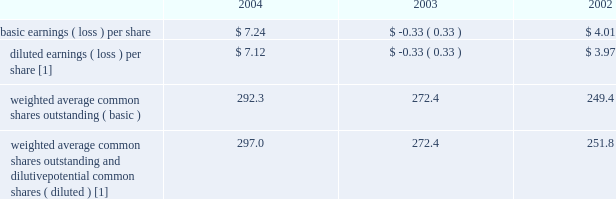Income was due primarily to the adoption of statement of position 03-1 , 201caccounting and reporting by insurance enterprises for certain nontraditional long-duration contracts and for separate accounts 201d ( 201csop 03-1 201d ) , which resulted in $ 1.6 billion of net investment income .
2003 compared to 2002 2014 revenues for the year ended december 31 , 2003 increased $ 2.3 billion over the comparable 2002 period .
Revenues increased due to earned premium growth within the business insurance , specialty commercial and personal lines segments , primarily as a result of earned pricing increases , higher earned premiums and net investment income in the retail products segment and net realized capital gains in 2003 as compared to net realized capital losses in 2002 .
Total benefits , claims and expenses increased $ 3.9 billion for the year ended december 31 , 2003 over the comparable prior year period primarily due to the company 2019s $ 2.6 billion asbestos reserve strengthening during the first quarter of 2003 and due to increases in the retail products segment associated with the growth in the individual annuity and institutional investments businesses .
The net loss for the year ended december 31 , 2003 was primarily due to the company 2019s first quarter 2003 asbestos reserve strengthening of $ 1.7 billion , after-tax .
Included in net loss for the year ended december 31 , 2003 are $ 40 of after-tax expense related to the settlement of litigation with bancorp services , llc ( 201cbancorp 201d ) and $ 27 of severance charges , after-tax , in property & casualty .
Included in net income for the year ended december 31 , 2002 are the $ 8 after-tax benefit recognized by hartford life , inc .
( 201chli 201d ) related to the reduction of hli 2019s reserves associated with september 11 and $ 11 of after-tax expense related to litigation with bancorp .
Net realized capital gains and losses see 201cinvestment results 201d in the investments section .
Income taxes the effective tax rate for 2004 , 2003 and 2002 was 15% ( 15 % ) , 83% ( 83 % ) and 6% ( 6 % ) , respectively .
The principal causes of the difference between the effective rates and the u.s .
Statutory rate of 35% ( 35 % ) were tax-exempt interest earned on invested assets , the dividends-received deduction , the tax benefit associated with the settlement of the 1998-2001 irs audit in 2004 and the tax benefit associated with the settlement of the 1996-1997 irs audit in 2002 .
Income taxes paid ( received ) in 2004 , 2003 and 2002 were $ 32 , ( $ 107 ) and ( $ 102 ) respectively .
For additional information , see note 13 of notes to consolidated financial statements .
Per common share the table represents earnings per common share data for the past three years: .
[1] as a result of the net loss for the year ended december 31 , 2003 , sfas no .
128 , 201cearnings per share 201d , requires the company to use basic weighted average common shares outstanding in the calculation of the year ended december 31 , 2003 diluted earnings ( loss ) per share , since the inclusion of options of 1.8 would have been antidilutive to the earnings per share calculation .
In the absence of the net loss , weighted average common shares outstanding and dilutive potential common shares would have totaled 274.2 .
Executive overview the company provides investment and retirement products such as variable and fixed annuities , mutual funds and retirement plan services and other institutional products ; individual and corporate owned life insurance ; and , group benefit products , such as group life and group disability insurance .
The company derives its revenues principally from : ( a ) fee income , including asset management fees , on separate account and mutual fund assets and mortality and expense fees , as well as cost of insurance charges ; ( b ) net investment income on general account assets ; ( c ) fully insured premiums ; and ( d ) certain other fees .
Asset management fees and mortality and expense fees are primarily generated from separate account assets , which are deposited with the company through the sale of variable annuity and variable universal life products and from mutual funds .
Cost of insurance charges are assessed on the net amount at risk for investment-oriented life insurance products .
Premium revenues are derived primarily from the sale of group life , and group disability and individual term insurance products .
The company 2019s expenses essentially consist of interest credited to policyholders on general account liabilities , insurance benefits provided , amortization of the deferred policy acquisition costs , expenses related to the selling and servicing the various products offered by the company , dividends to policyholders , and other general business expenses. .
What is the net change in the number of outstanding shares from 2003 to 2004 , ( in millions ) ? 
Computations: (292.3 - 272.4)
Answer: 19.9. 